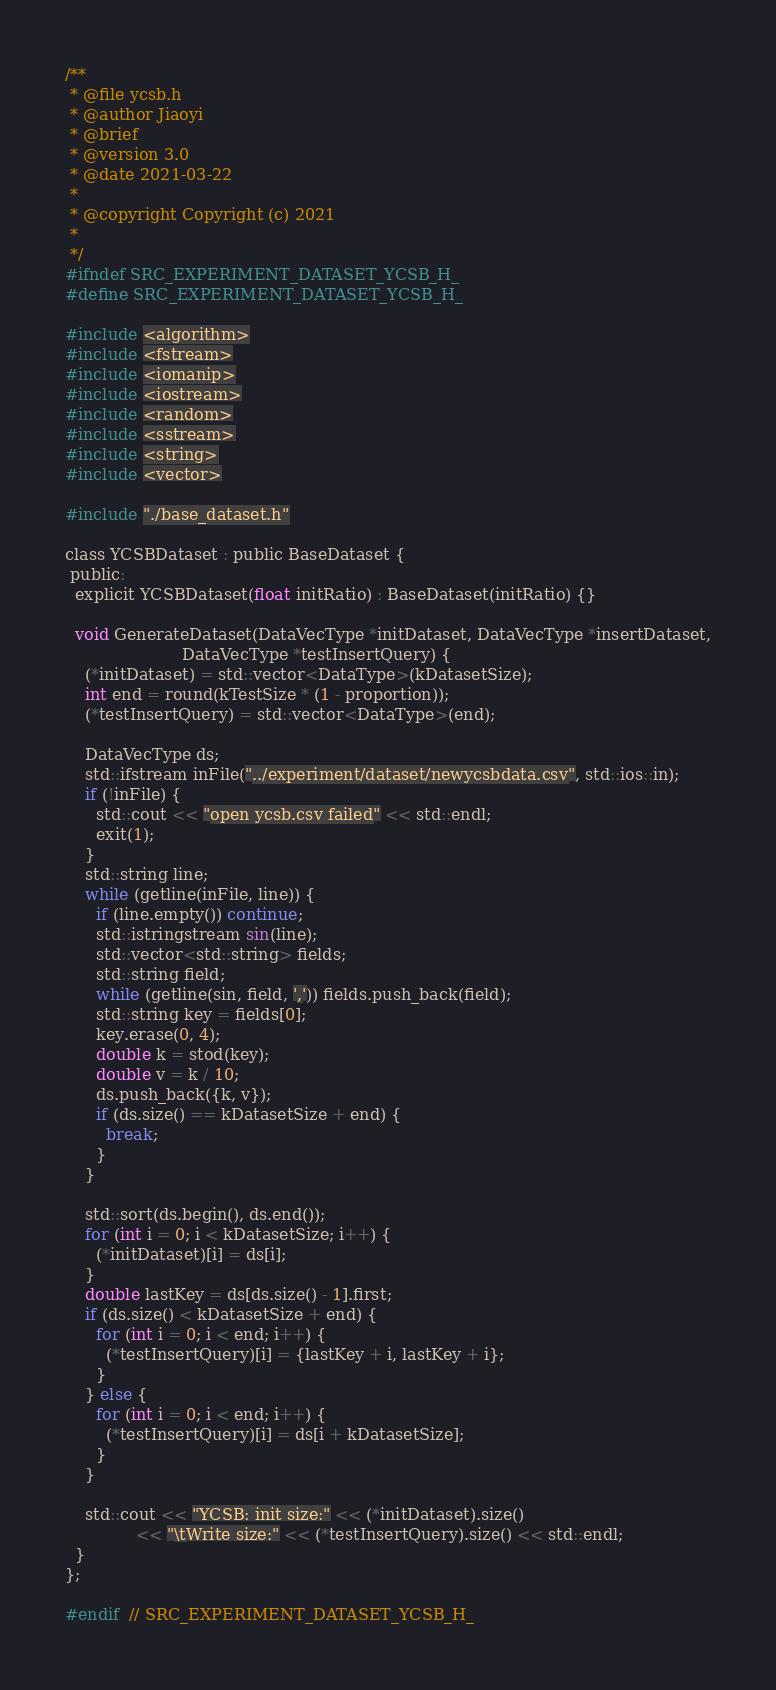Convert code to text. <code><loc_0><loc_0><loc_500><loc_500><_C_>/**
 * @file ycsb.h
 * @author Jiaoyi
 * @brief
 * @version 3.0
 * @date 2021-03-22
 *
 * @copyright Copyright (c) 2021
 *
 */
#ifndef SRC_EXPERIMENT_DATASET_YCSB_H_
#define SRC_EXPERIMENT_DATASET_YCSB_H_

#include <algorithm>
#include <fstream>
#include <iomanip>
#include <iostream>
#include <random>
#include <sstream>
#include <string>
#include <vector>

#include "./base_dataset.h"

class YCSBDataset : public BaseDataset {
 public:
  explicit YCSBDataset(float initRatio) : BaseDataset(initRatio) {}

  void GenerateDataset(DataVecType *initDataset, DataVecType *insertDataset,
                       DataVecType *testInsertQuery) {
    (*initDataset) = std::vector<DataType>(kDatasetSize);
    int end = round(kTestSize * (1 - proportion));
    (*testInsertQuery) = std::vector<DataType>(end);

    DataVecType ds;
    std::ifstream inFile("../experiment/dataset/newycsbdata.csv", std::ios::in);
    if (!inFile) {
      std::cout << "open ycsb.csv failed" << std::endl;
      exit(1);
    }
    std::string line;
    while (getline(inFile, line)) {
      if (line.empty()) continue;
      std::istringstream sin(line);
      std::vector<std::string> fields;
      std::string field;
      while (getline(sin, field, ',')) fields.push_back(field);
      std::string key = fields[0];
      key.erase(0, 4);
      double k = stod(key);
      double v = k / 10;
      ds.push_back({k, v});
      if (ds.size() == kDatasetSize + end) {
        break;
      }
    }

    std::sort(ds.begin(), ds.end());
    for (int i = 0; i < kDatasetSize; i++) {
      (*initDataset)[i] = ds[i];
    }
    double lastKey = ds[ds.size() - 1].first;
    if (ds.size() < kDatasetSize + end) {
      for (int i = 0; i < end; i++) {
        (*testInsertQuery)[i] = {lastKey + i, lastKey + i};
      }
    } else {
      for (int i = 0; i < end; i++) {
        (*testInsertQuery)[i] = ds[i + kDatasetSize];
      }
    }

    std::cout << "YCSB: init size:" << (*initDataset).size()
              << "\tWrite size:" << (*testInsertQuery).size() << std::endl;
  }
};

#endif  // SRC_EXPERIMENT_DATASET_YCSB_H_
</code> 